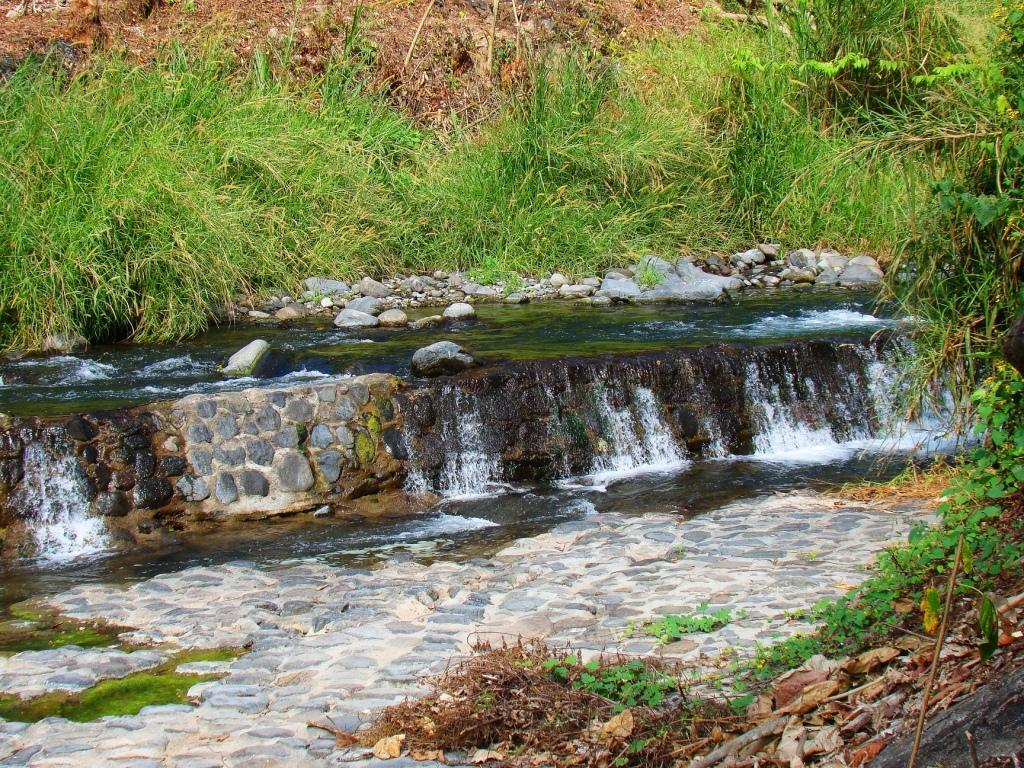What natural feature is the main subject of the image? There is a waterfall in the image. What can be seen near the waterfall? Rocks are visible near the waterfall. What type of vegetation is present around the waterfall? Grass is present around the waterfall. Can you hear the sound of a cord being pulled in the image? There is no mention of a cord or any sound in the image, as it features a waterfall and its surroundings. 